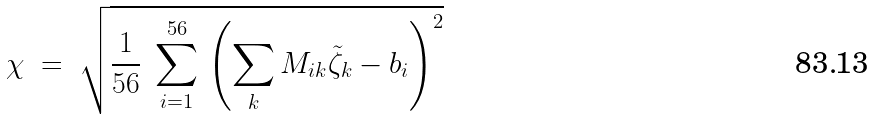Convert formula to latex. <formula><loc_0><loc_0><loc_500><loc_500>\chi \ = \ \sqrt { \frac { 1 } { 5 6 } \ \sum _ { i = 1 } ^ { 5 6 } \, \left ( \sum _ { k } M _ { i k } \tilde { \zeta } _ { k } - b _ { i } \right ) ^ { 2 } }</formula> 